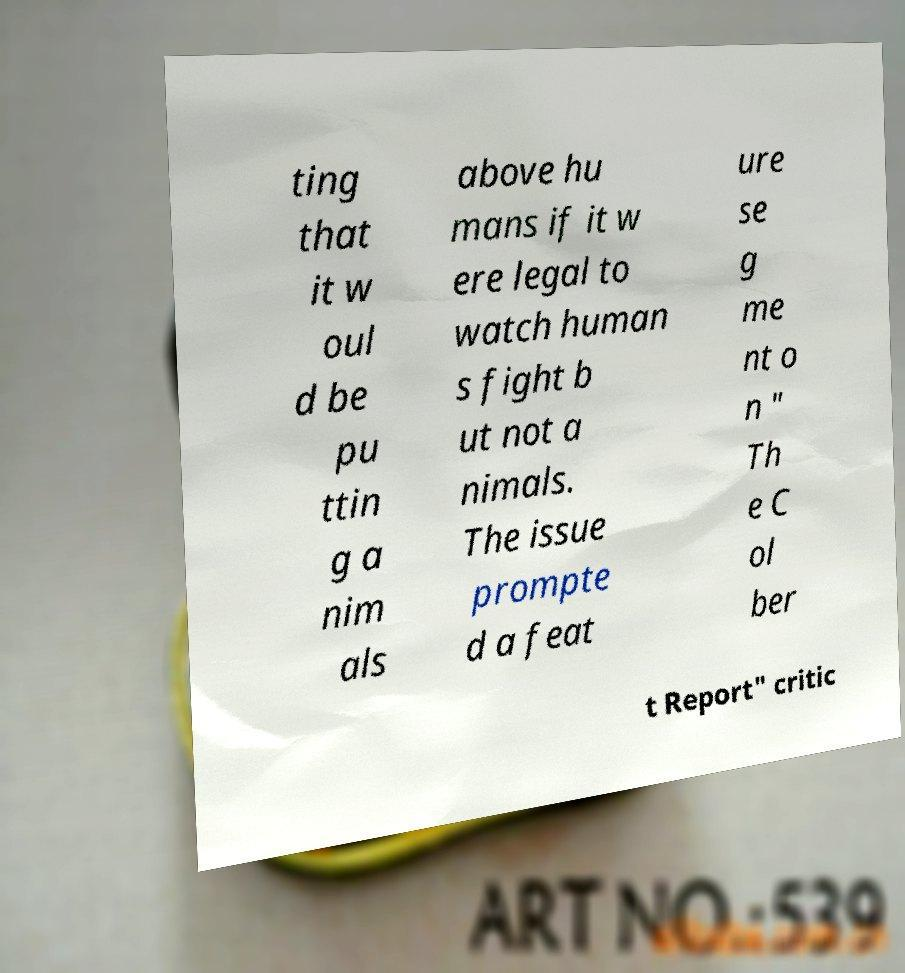Can you read and provide the text displayed in the image?This photo seems to have some interesting text. Can you extract and type it out for me? ting that it w oul d be pu ttin g a nim als above hu mans if it w ere legal to watch human s fight b ut not a nimals. The issue prompte d a feat ure se g me nt o n " Th e C ol ber t Report" critic 